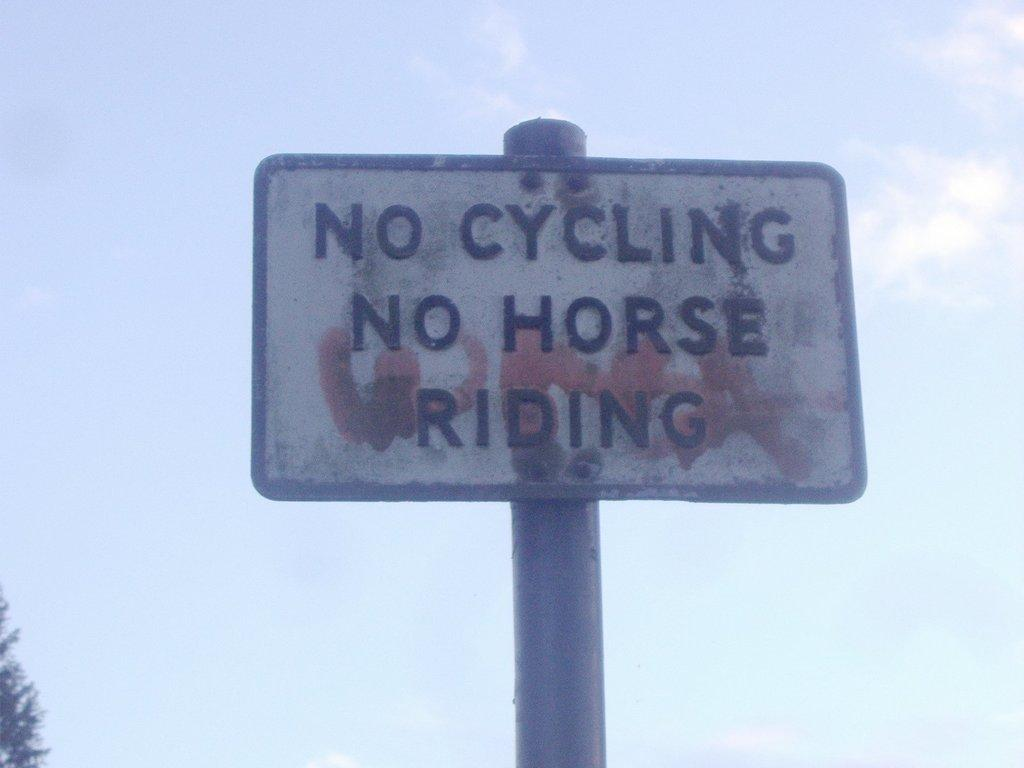Provide a one-sentence caption for the provided image. A sign displays that one may not ride a bicycle or a horse in this area. 